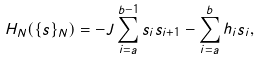<formula> <loc_0><loc_0><loc_500><loc_500>H _ { N } ( \{ s \} _ { N } ) = - J \sum _ { i = a } ^ { b - 1 } s _ { i } s _ { i + 1 } - \sum _ { i = a } ^ { b } h _ { i } s _ { i } ,</formula> 